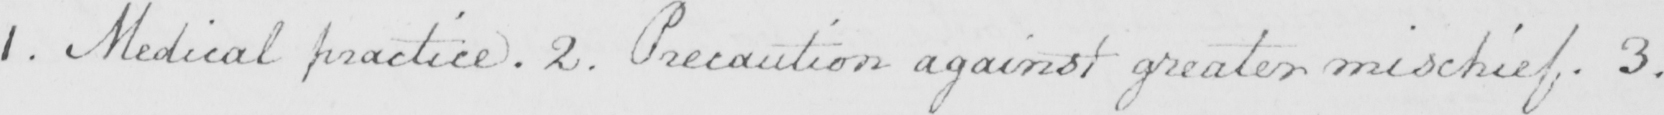Can you read and transcribe this handwriting? 1 . Medical practice . 2 . Precaution against greater mischief . 3 . 